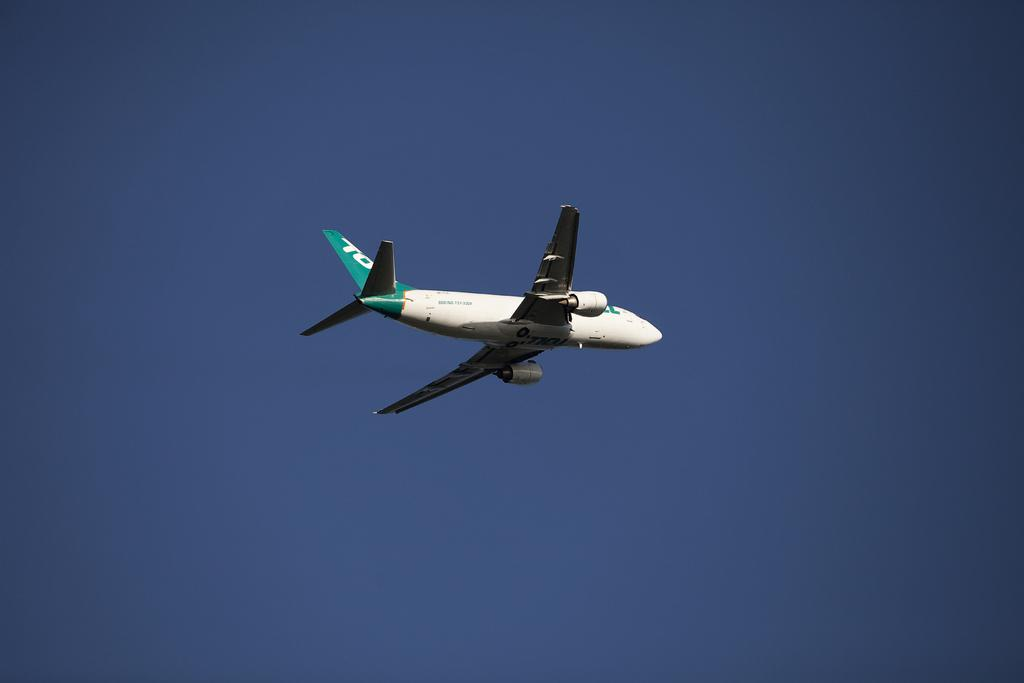What is the main subject of the image? The main subject of the image is an airplane. What is the airplane doing in the image? The airplane is flying in the air. What can be seen in the background of the image? The sky is visible in the background of the image. How many boys are involved in the plot of the image? There are no boys or plot present in the image; it features an airplane flying in the sky. 